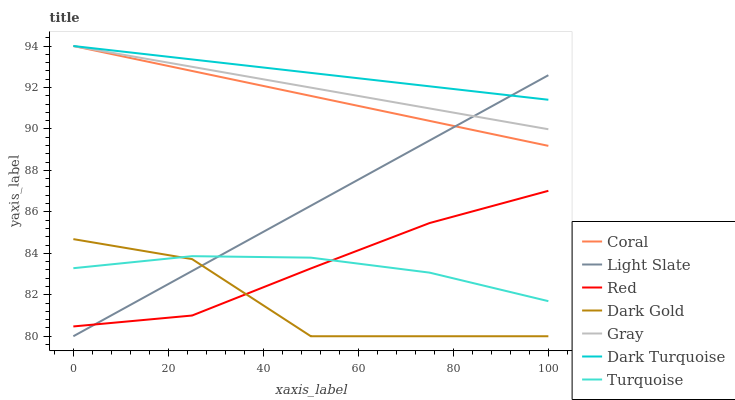Does Dark Gold have the minimum area under the curve?
Answer yes or no. Yes. Does Dark Turquoise have the maximum area under the curve?
Answer yes or no. Yes. Does Turquoise have the minimum area under the curve?
Answer yes or no. No. Does Turquoise have the maximum area under the curve?
Answer yes or no. No. Is Light Slate the smoothest?
Answer yes or no. Yes. Is Dark Gold the roughest?
Answer yes or no. Yes. Is Turquoise the smoothest?
Answer yes or no. No. Is Turquoise the roughest?
Answer yes or no. No. Does Dark Gold have the lowest value?
Answer yes or no. Yes. Does Turquoise have the lowest value?
Answer yes or no. No. Does Coral have the highest value?
Answer yes or no. Yes. Does Dark Gold have the highest value?
Answer yes or no. No. Is Red less than Gray?
Answer yes or no. Yes. Is Gray greater than Turquoise?
Answer yes or no. Yes. Does Red intersect Turquoise?
Answer yes or no. Yes. Is Red less than Turquoise?
Answer yes or no. No. Is Red greater than Turquoise?
Answer yes or no. No. Does Red intersect Gray?
Answer yes or no. No. 